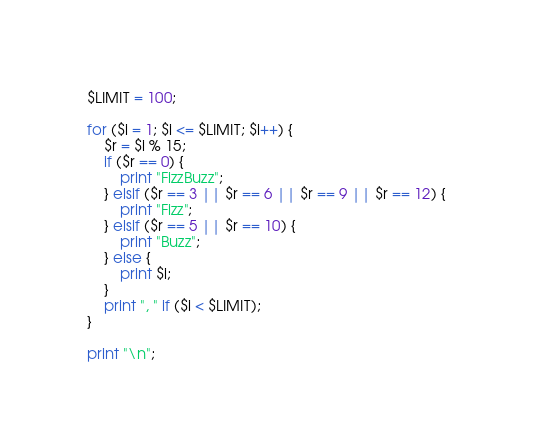Convert code to text. <code><loc_0><loc_0><loc_500><loc_500><_Perl_>$LIMIT = 100;

for ($i = 1; $i <= $LIMIT; $i++) {
	$r = $i % 15;
	if ($r == 0) {
		print "FizzBuzz";
	} elsif ($r == 3 || $r == 6 || $r == 9 || $r == 12) {
		print "Fizz";
	} elsif ($r == 5 || $r == 10) {
		print "Buzz";
	} else {
		print $i;
	}
	print ", " if ($i < $LIMIT);
}

print "\n";
</code> 